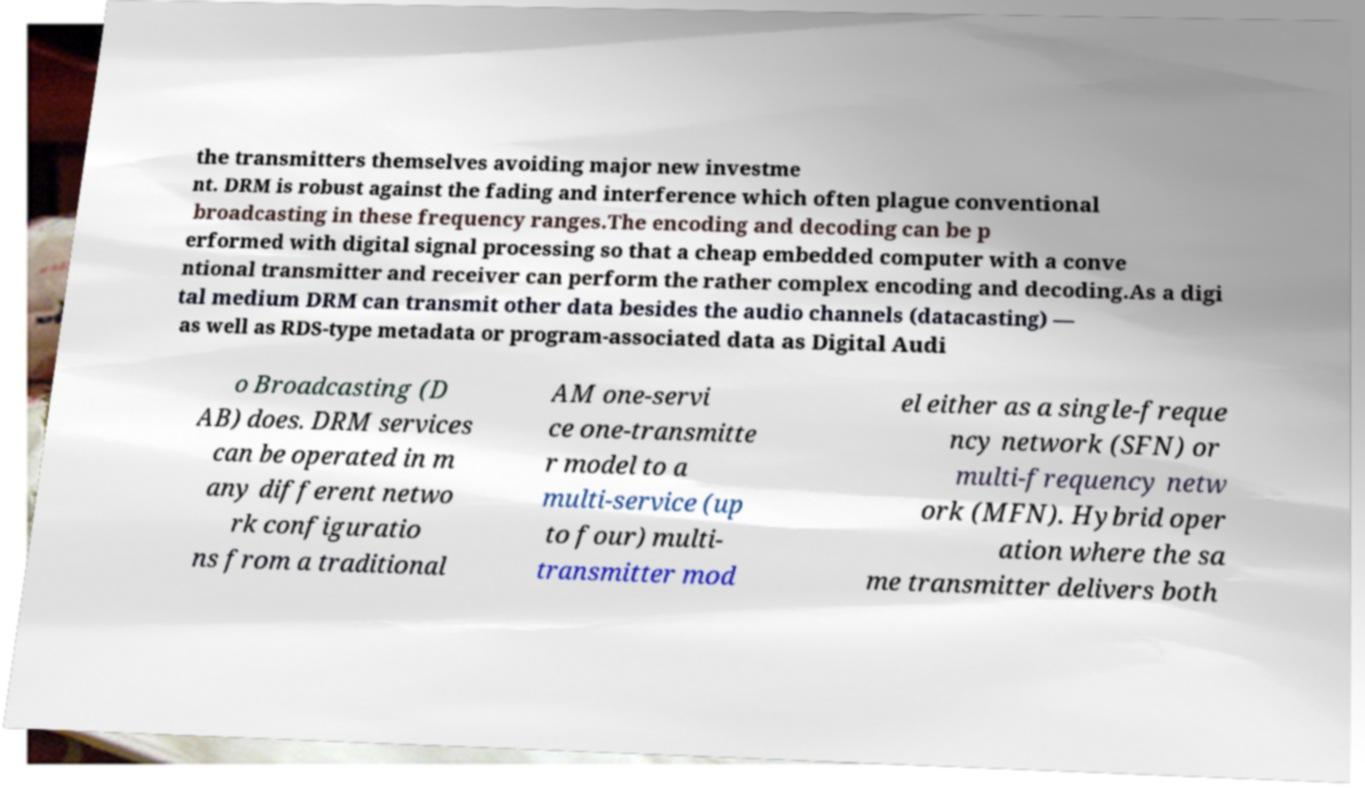Please identify and transcribe the text found in this image. the transmitters themselves avoiding major new investme nt. DRM is robust against the fading and interference which often plague conventional broadcasting in these frequency ranges.The encoding and decoding can be p erformed with digital signal processing so that a cheap embedded computer with a conve ntional transmitter and receiver can perform the rather complex encoding and decoding.As a digi tal medium DRM can transmit other data besides the audio channels (datacasting) — as well as RDS-type metadata or program-associated data as Digital Audi o Broadcasting (D AB) does. DRM services can be operated in m any different netwo rk configuratio ns from a traditional AM one-servi ce one-transmitte r model to a multi-service (up to four) multi- transmitter mod el either as a single-freque ncy network (SFN) or multi-frequency netw ork (MFN). Hybrid oper ation where the sa me transmitter delivers both 